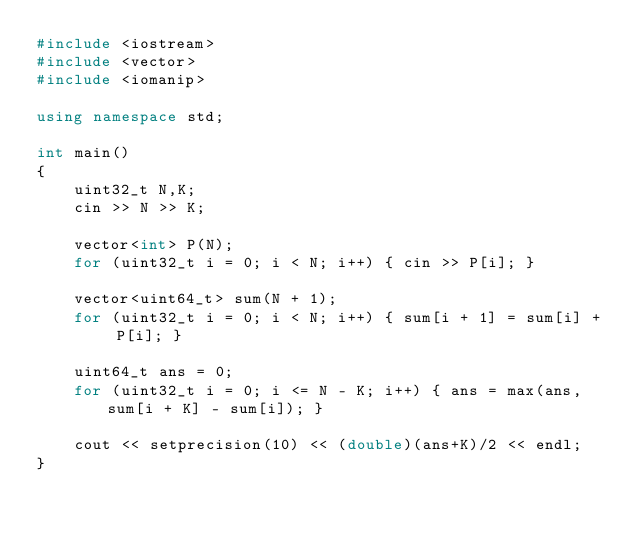<code> <loc_0><loc_0><loc_500><loc_500><_C++_>#include <iostream>
#include <vector>
#include <iomanip>

using namespace std;

int main()
{
    uint32_t N,K;
    cin >> N >> K;

    vector<int> P(N);
    for (uint32_t i = 0; i < N; i++) { cin >> P[i]; }

    vector<uint64_t> sum(N + 1);
    for (uint32_t i = 0; i < N; i++) { sum[i + 1] = sum[i] + P[i]; }

    uint64_t ans = 0;
    for (uint32_t i = 0; i <= N - K; i++) { ans = max(ans, sum[i + K] - sum[i]); }

    cout << setprecision(10) << (double)(ans+K)/2 << endl;
}
</code> 